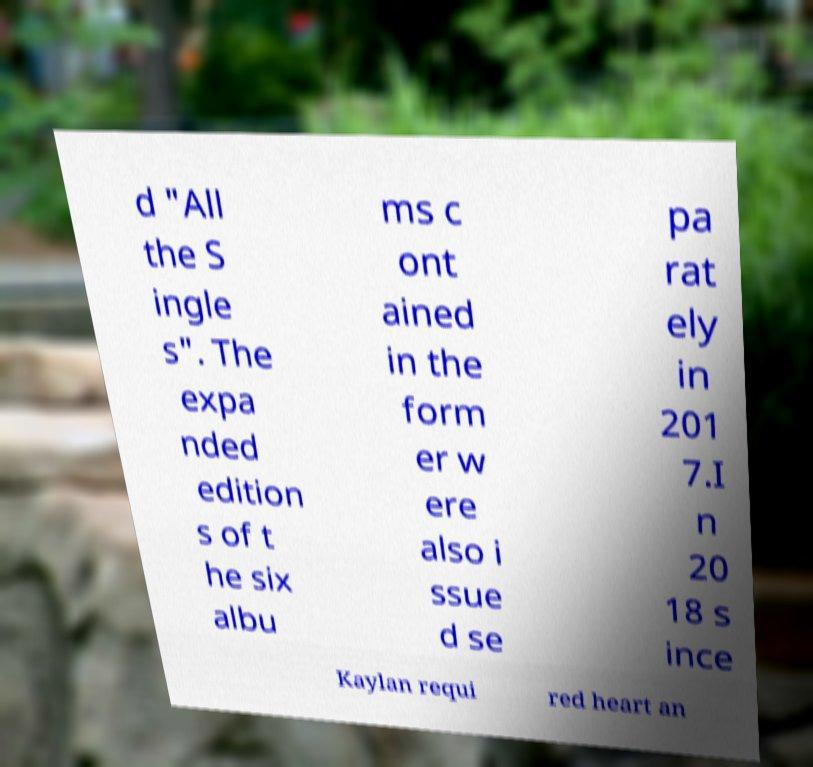Please identify and transcribe the text found in this image. d "All the S ingle s". The expa nded edition s of t he six albu ms c ont ained in the form er w ere also i ssue d se pa rat ely in 201 7.I n 20 18 s ince Kaylan requi red heart an 